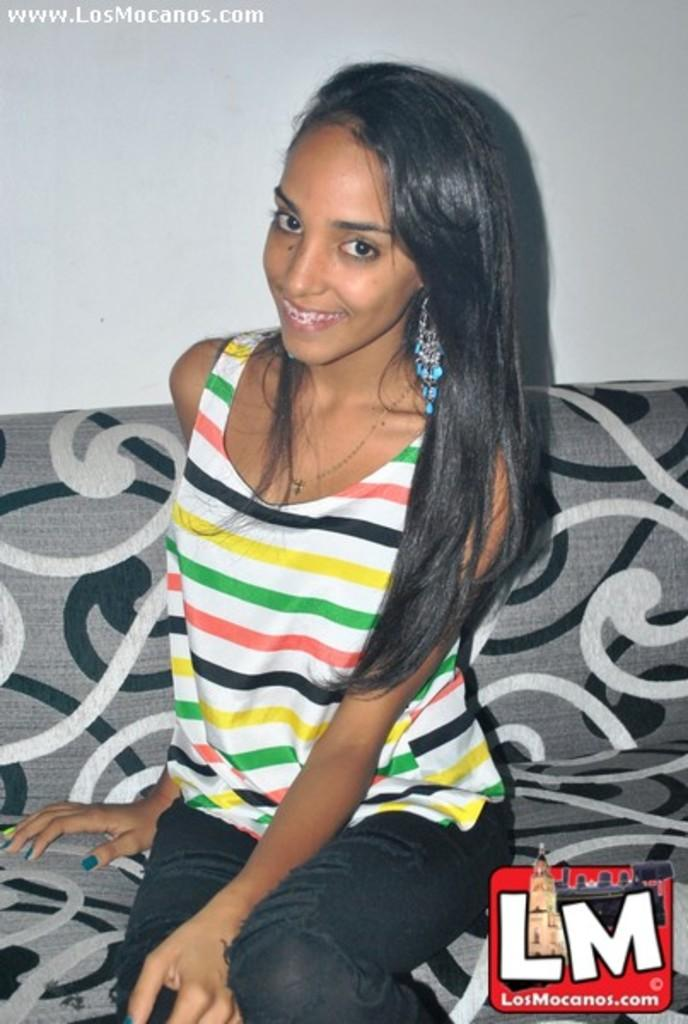What type of furniture is in the image? There is a sofa in the image. Who is sitting on the sofa? A girl is sitting on the sofa. What color is the background of the image? The background of the image is white. Where is the salt container located in the image? There is no salt container present in the image. What type of natural disaster is depicted in the image? There is no volcano or any natural disaster depicted in the image; it features a girl sitting on a sofa with a white background. 